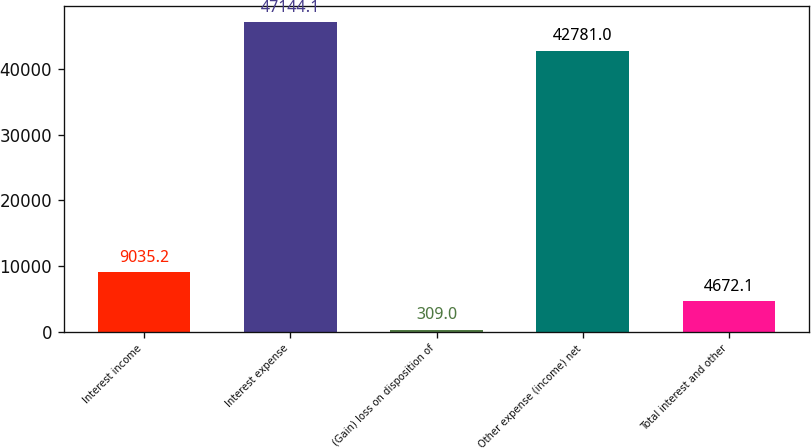Convert chart. <chart><loc_0><loc_0><loc_500><loc_500><bar_chart><fcel>Interest income<fcel>Interest expense<fcel>(Gain) loss on disposition of<fcel>Other expense (income) net<fcel>Total interest and other<nl><fcel>9035.2<fcel>47144.1<fcel>309<fcel>42781<fcel>4672.1<nl></chart> 